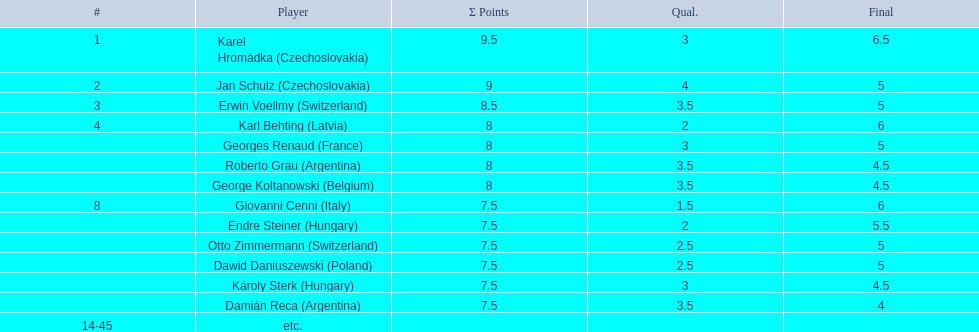How many players had final scores higher than 5? 4. 